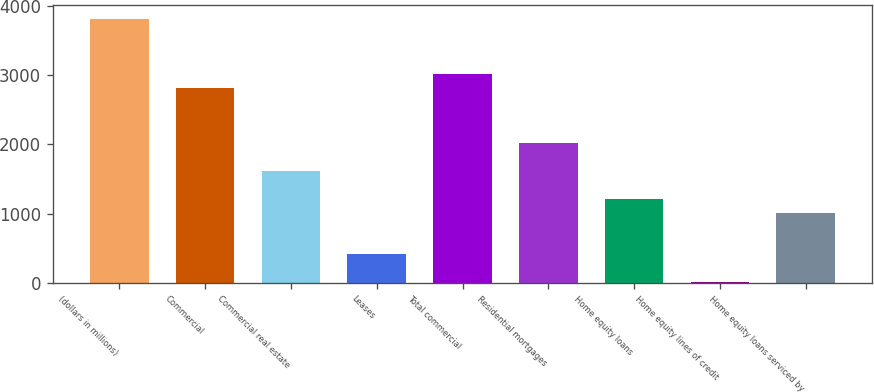Convert chart to OTSL. <chart><loc_0><loc_0><loc_500><loc_500><bar_chart><fcel>(dollars in millions)<fcel>Commercial<fcel>Commercial real estate<fcel>Leases<fcel>Total commercial<fcel>Residential mortgages<fcel>Home equity loans<fcel>Home equity lines of credit<fcel>Home equity loans serviced by<nl><fcel>3816.7<fcel>2815.2<fcel>1613.4<fcel>411.6<fcel>3015.5<fcel>2014<fcel>1212.8<fcel>11<fcel>1012.5<nl></chart> 